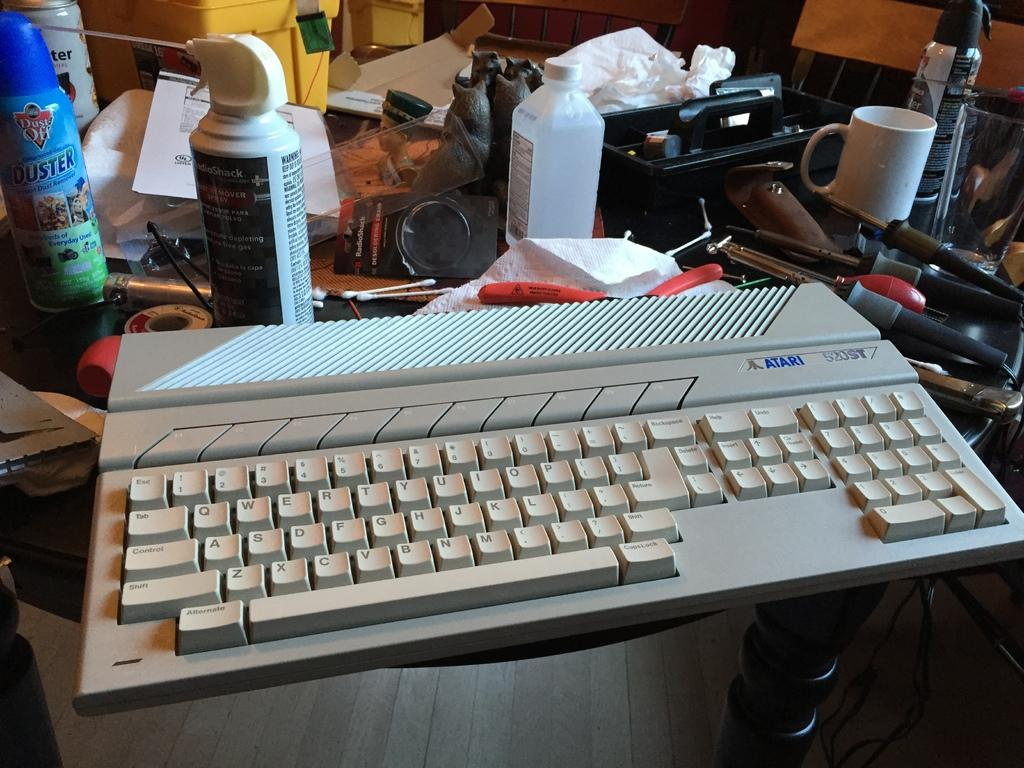<image>
Relay a brief, clear account of the picture shown. White Atari keyboard next to a white cup. 